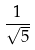Convert formula to latex. <formula><loc_0><loc_0><loc_500><loc_500>\frac { 1 } { \sqrt { 5 } }</formula> 